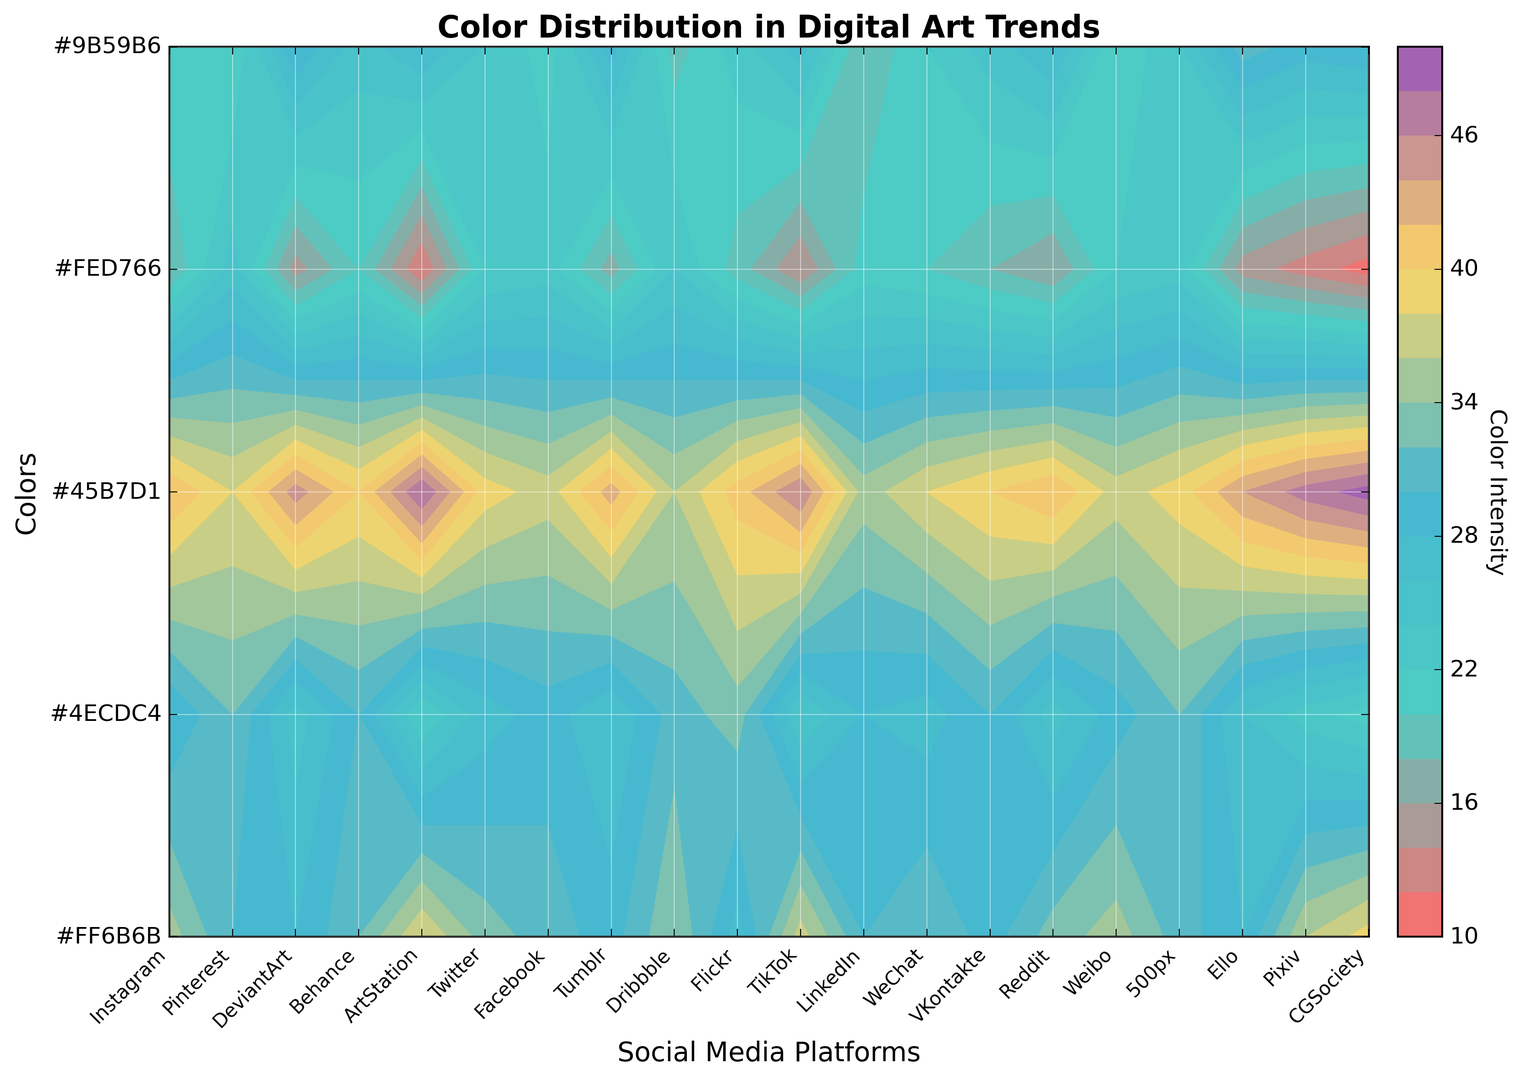Which platform has the highest intensity for the blue color? Look at the y-axis labeled "Colors" and find "blue". Follow the contour line upwards to see which platform on the x-axis has the highest contour level.
Answer: CGSociety How does the average green color intensity compare between Instagram and Pinterest? Identify the green color row and then compare the values for Instagram and Pinterest. Average out the values (Instagram: 28, Pinterest: 32) -> (28 + 32) / 2. Compare the average with individual values.
Answer: Equal Across all platforms, which color has the most uniform distribution? Evaluate the contour spread of each color across all platforms. The more uniform the distribution, the less variation in contour levels across the x-axis.
Answer: Green Which platform exhibits the most variety in color intensity? Assess the gradients and contour lines across each platform column. The platform with the most mixed color intensities in its column indicates the most variety.
Answer: ArtStation Between Instagram and TikTok, which platform has a higher intensity for purple and by how much? Locate the purple color row and compare the contour levels for Instagram and TikTok. Subtract the two values to find the difference. (TikTok > Instagram, 27 - 22)
Answer: TikTok by 5 Which three platforms show a higher intensity of yellow compared to the average intensity of yellow across all platforms? Calculate the average intensity of yellow across all platforms. Compare each platform's value against this average. (19/20/21/22 average = 17.95). Identify platforms above average.
Answer: Pinterest, Dribbble, Facebook What is the combined intensity of red and purple for Behance? Find the contour levels for red and purple for Behance. Add these two values together to get the combined intensity. (32 red + 25 purple)
Answer: 57 Which color appears to be the least intense on Tumblr? Observe the contour levels on the Tumblr column for each color. Identify the color with the lowest contour level in that column.
Answer: Yellow Identify the platform with the lowest green color intensity. Follow the green row and determine which platform shows the lowest contour level (smallest intensity).
Answer: CGSociety Is the intensity of blue on LinkedIn higher or lower than the intensity of purple on Facebook? Locate the contour levels for blue on LinkedIn and purple on Facebook. Compare these values directly. (LinkedIn blue: 35, Facebook purple: 21)
Answer: Higher 